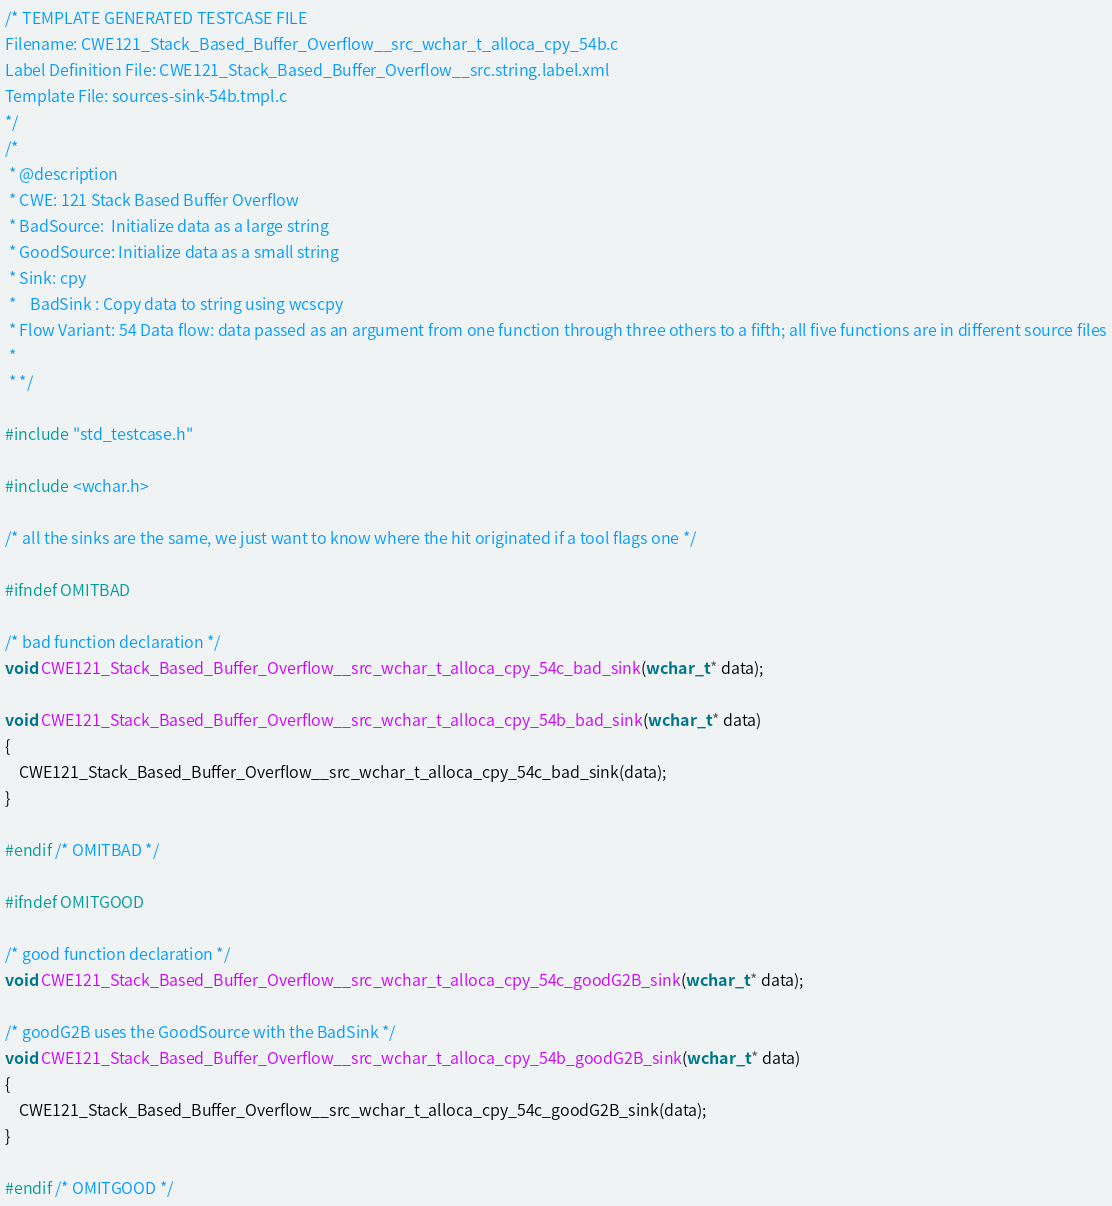Convert code to text. <code><loc_0><loc_0><loc_500><loc_500><_C_>/* TEMPLATE GENERATED TESTCASE FILE
Filename: CWE121_Stack_Based_Buffer_Overflow__src_wchar_t_alloca_cpy_54b.c
Label Definition File: CWE121_Stack_Based_Buffer_Overflow__src.string.label.xml
Template File: sources-sink-54b.tmpl.c
*/
/*
 * @description
 * CWE: 121 Stack Based Buffer Overflow
 * BadSource:  Initialize data as a large string
 * GoodSource: Initialize data as a small string
 * Sink: cpy
 *    BadSink : Copy data to string using wcscpy
 * Flow Variant: 54 Data flow: data passed as an argument from one function through three others to a fifth; all five functions are in different source files
 *
 * */

#include "std_testcase.h"

#include <wchar.h>

/* all the sinks are the same, we just want to know where the hit originated if a tool flags one */

#ifndef OMITBAD

/* bad function declaration */
void CWE121_Stack_Based_Buffer_Overflow__src_wchar_t_alloca_cpy_54c_bad_sink(wchar_t * data);

void CWE121_Stack_Based_Buffer_Overflow__src_wchar_t_alloca_cpy_54b_bad_sink(wchar_t * data)
{
    CWE121_Stack_Based_Buffer_Overflow__src_wchar_t_alloca_cpy_54c_bad_sink(data);
}

#endif /* OMITBAD */

#ifndef OMITGOOD

/* good function declaration */
void CWE121_Stack_Based_Buffer_Overflow__src_wchar_t_alloca_cpy_54c_goodG2B_sink(wchar_t * data);

/* goodG2B uses the GoodSource with the BadSink */
void CWE121_Stack_Based_Buffer_Overflow__src_wchar_t_alloca_cpy_54b_goodG2B_sink(wchar_t * data)
{
    CWE121_Stack_Based_Buffer_Overflow__src_wchar_t_alloca_cpy_54c_goodG2B_sink(data);
}

#endif /* OMITGOOD */
</code> 